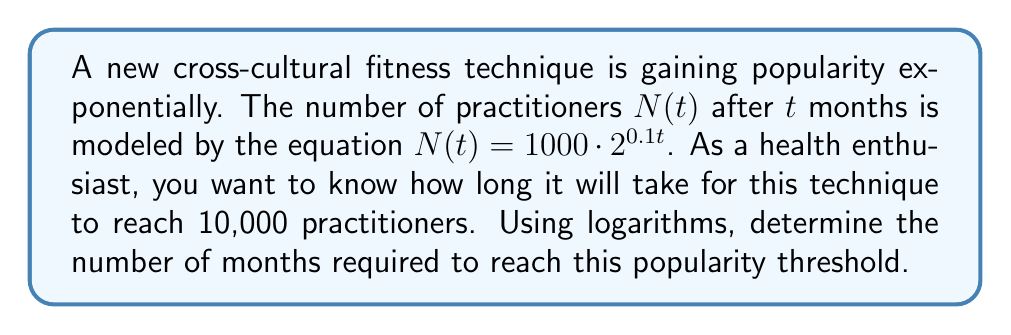Give your solution to this math problem. Let's approach this step-by-step:

1) We start with the given equation: $N(t) = 1000 \cdot 2^{0.1t}$

2) We want to find $t$ when $N(t) = 10000$. So, let's set up the equation:

   $10000 = 1000 \cdot 2^{0.1t}$

3) Divide both sides by 1000:

   $10 = 2^{0.1t}$

4) Now, we can apply logarithms to both sides. Let's use log base 2:

   $\log_2(10) = \log_2(2^{0.1t})$

5) Using the logarithm property $\log_a(a^x) = x$, we can simplify the right side:

   $\log_2(10) = 0.1t$

6) Now, we can solve for $t$:

   $t = \frac{\log_2(10)}{0.1}$

7) We can calculate this:
   
   $t = \frac{3.32193...}{0.1} = 33.2193...$

8) Since we're dealing with months, we should round up to the nearest whole number.
Answer: It will take 34 months for the new fitness technique to reach 10,000 practitioners. 